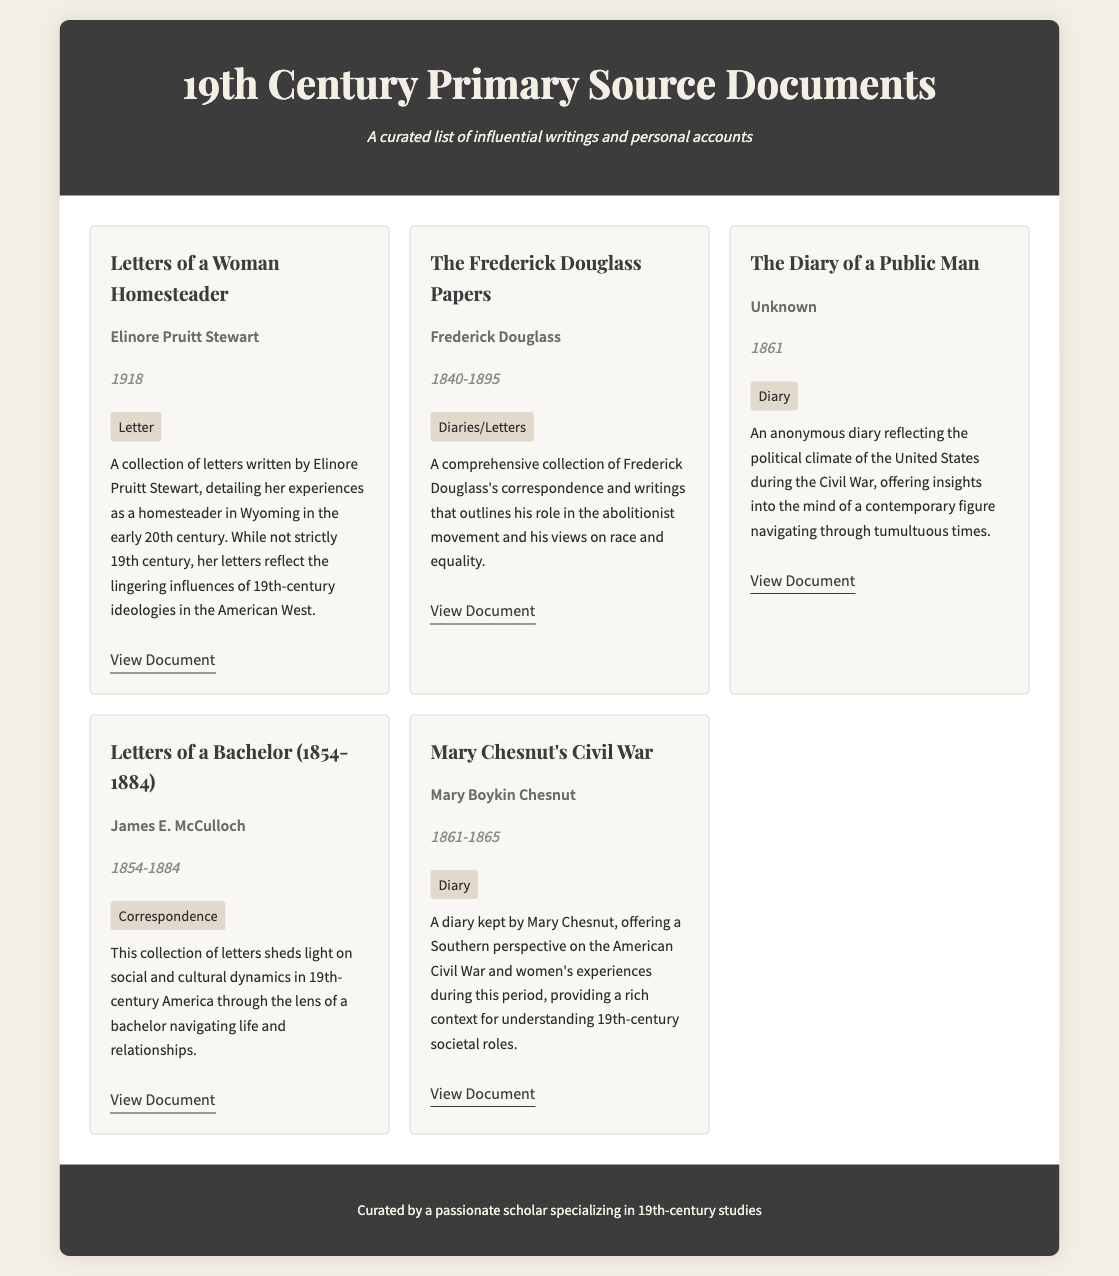What is the title of the first document? The title of the first document listed in the catalog is "Letters of a Woman Homesteader."
Answer: Letters of a Woman Homesteader Who is the author of "Mary Chesnut's Civil War"? The author of "Mary Chesnut's Civil War" is Mary Boykin Chesnut.
Answer: Mary Boykin Chesnut What year range does "The Frederick Douglass Papers" cover? The year range for "The Frederick Douglass Papers" is from 1840 to 1895.
Answer: 1840-1895 Which document type is associated with James E. McCulloch's writings? The document type associated with James E. McCulloch's writings is "Correspondence."
Answer: Correspondence How many documents are listed in the catalog? There are five documents listed in the catalog.
Answer: Five What unique perspective does "Mary Chesnut's Civil War" provide? "Mary Chesnut's Civil War" provides a Southern perspective on the American Civil War.
Answer: Southern perspective Which document contains letters detailing homesteading experiences? The document that contains letters detailing homesteading experiences is "Letters of a Woman Homesteader."
Answer: Letters of a Woman Homesteader What repeated event is central to the diary entry of "The Diary of a Public Man"? The central event of "The Diary of a Public Man" is the American Civil War.
Answer: American Civil War 